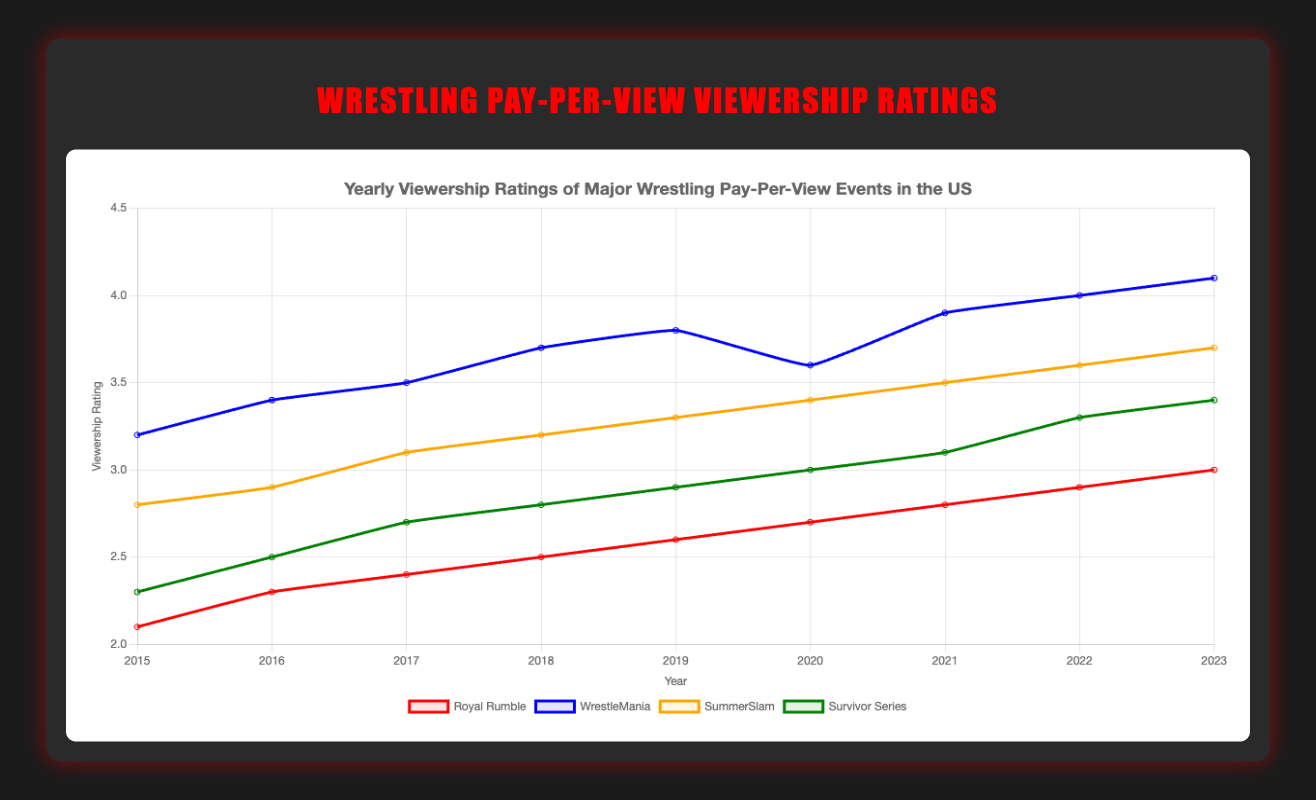What's the average viewership rating of WrestleMania over the years shown? To find the average, sum up all the WrestleMania ratings from 2015 to 2023: 3.2 + 3.4 + 3.5 + 3.7 + 3.8 + 3.6 + 3.9 + 4.0 + 4.1 = 33.2. Then divide by the number of years (9). Thus, 33.2 / 9 ≈ 3.69.
Answer: 3.69 Which event had the highest viewership rating in 2019? By comparing the ratings in 2019 for each event: Royal Rumble (2.6), WrestleMania (3.8), SummerSlam (3.3), Survivor Series (2.9), WrestleMania has the highest rating with 3.8.
Answer: WrestleMania What is the difference in rating between SummerSlam and Survivor Series in 2023? The rating of SummerSlam in 2023 is 3.7, and for Survivor Series, it is 3.4. The difference is 3.7 - 3.4 = 0.3.
Answer: 0.3 Which event showed a consistent increase in viewership rating from 2015 to 2023? By examining the trends of each event over the years, Royal Rumble shows an increase every year from 2.1 in 2015 to 3.0 in 2023.
Answer: Royal Rumble In what year did SummerSlam first surpass a 3.0 rating? By checking the SummerSlam ratings over the years, it first surpasses a 3.0 rating in 2017 with a rating of 3.1.
Answer: 2017 Which event had the lowest viewership rating in 2015? By comparing the 2015 ratings for each event: Royal Rumble (2.1), WrestleMania (3.2), SummerSlam (2.8), Survivor Series (2.3), Royal Rumble had the lowest rating of 2.1.
Answer: Royal Rumble How many events had a rating of 3.0 or more in 2020? By looking at the 2020 ratings: Royal Rumble (2.7), WrestleMania (3.6), SummerSlam (3.4), Survivor Series (3.0), three events (WrestleMania, SummerSlam, Survivor Series) had a rating of 3.0 or more.
Answer: 3 Calculate the total sum of ratings for Survivor Series from 2015 to 2023. Add up the Survivor Series ratings: 2.3 + 2.5 + 2.7 + 2.8 + 2.9 + 3.0 + 3.1 + 3.3 + 3.4 = 26
Answer: 26 